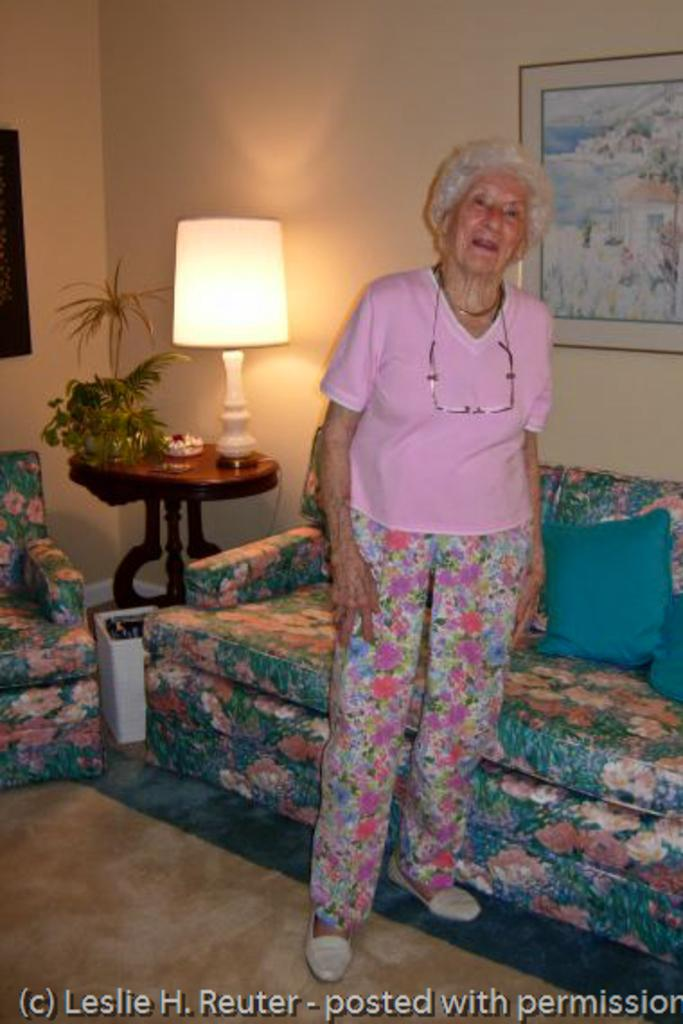What is the primary subject in the image? There is a woman standing in the image. Where is the woman standing? The woman is standing on the floor. What type of furniture is present in the image? There are sofas and a table in the image. What objects can be seen on the table? There is a lamp and a plant on the table. What is visible in the background of the image? There is a wall in the background of the image. What is hanging on the wall? There is a frame on the wall. How many stems are visible on the woman in the image? There are no stems visible on the woman in the image. What type of cup is being used by the person sitting on the sofa? There is no person sitting on the sofa, nor is there a cup present in the image. 